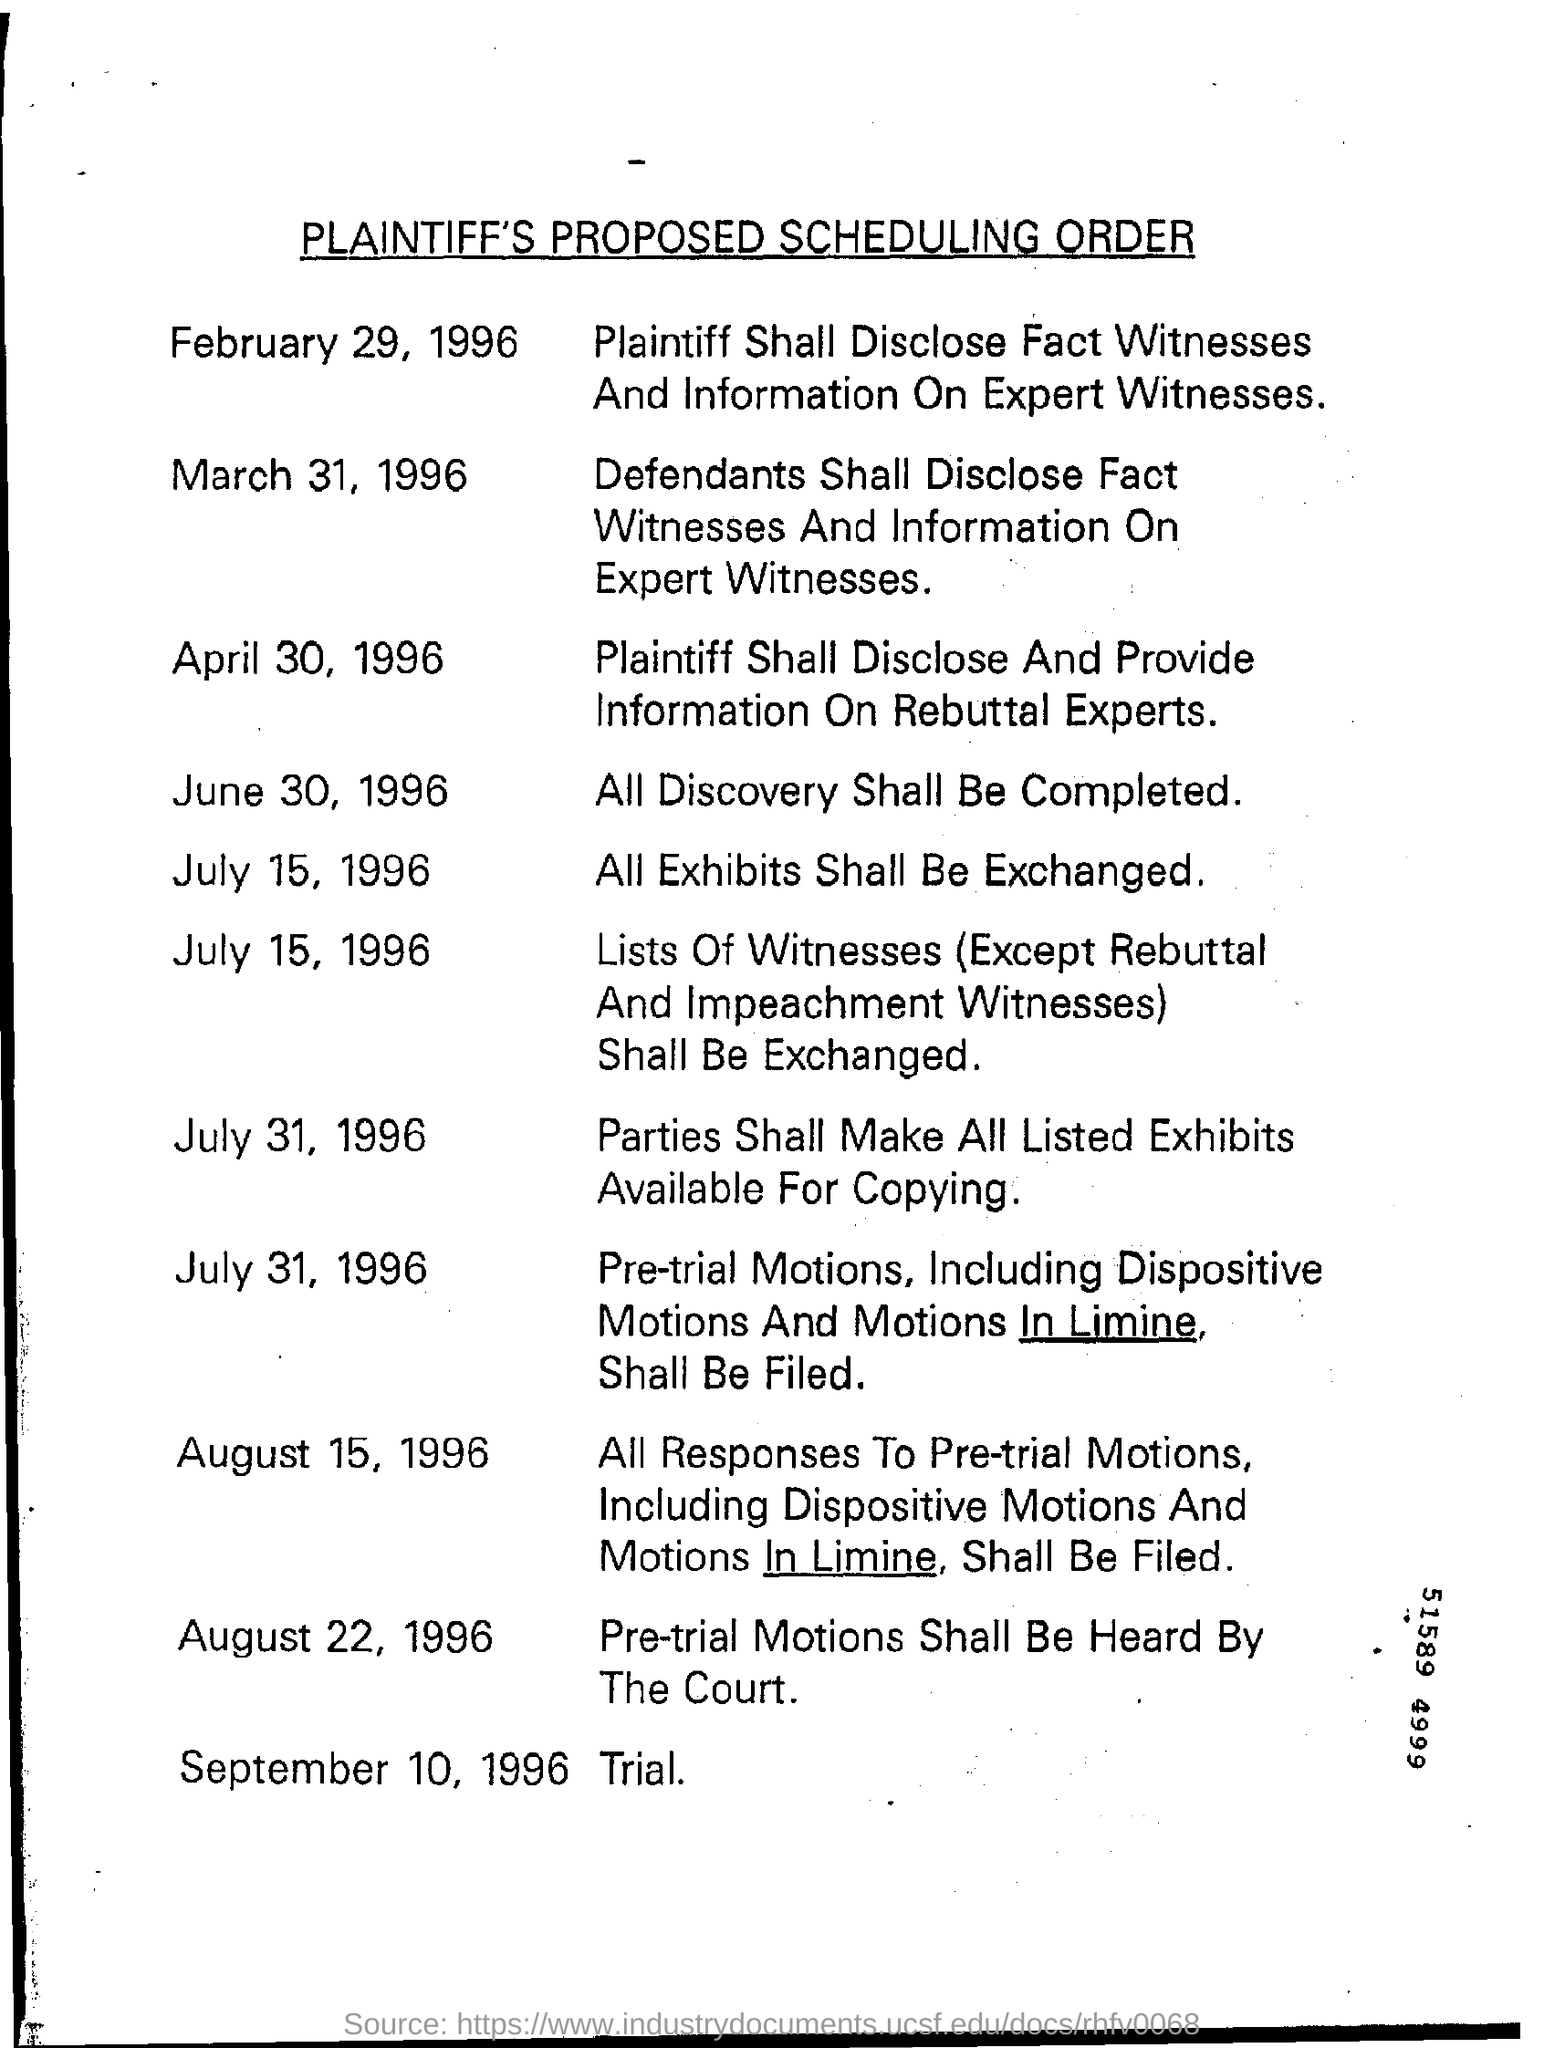Give some essential details in this illustration. The trial that was scheduled to take place on September 10, 1996, has been postponed due to unforeseen circumstances. The heading of this document is 'Plaintiff's Proposed Scheduling Order.' On July 31, 1996, the parties shall make all listed exhibits available for copying. 